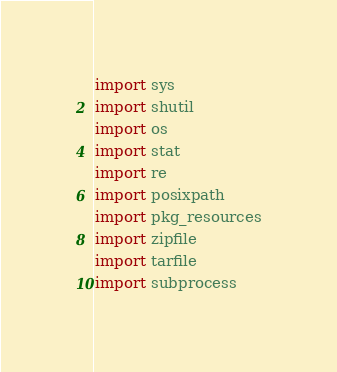Convert code to text. <code><loc_0><loc_0><loc_500><loc_500><_Python_>import sys
import shutil
import os
import stat
import re
import posixpath
import pkg_resources
import zipfile
import tarfile
import subprocess</code> 